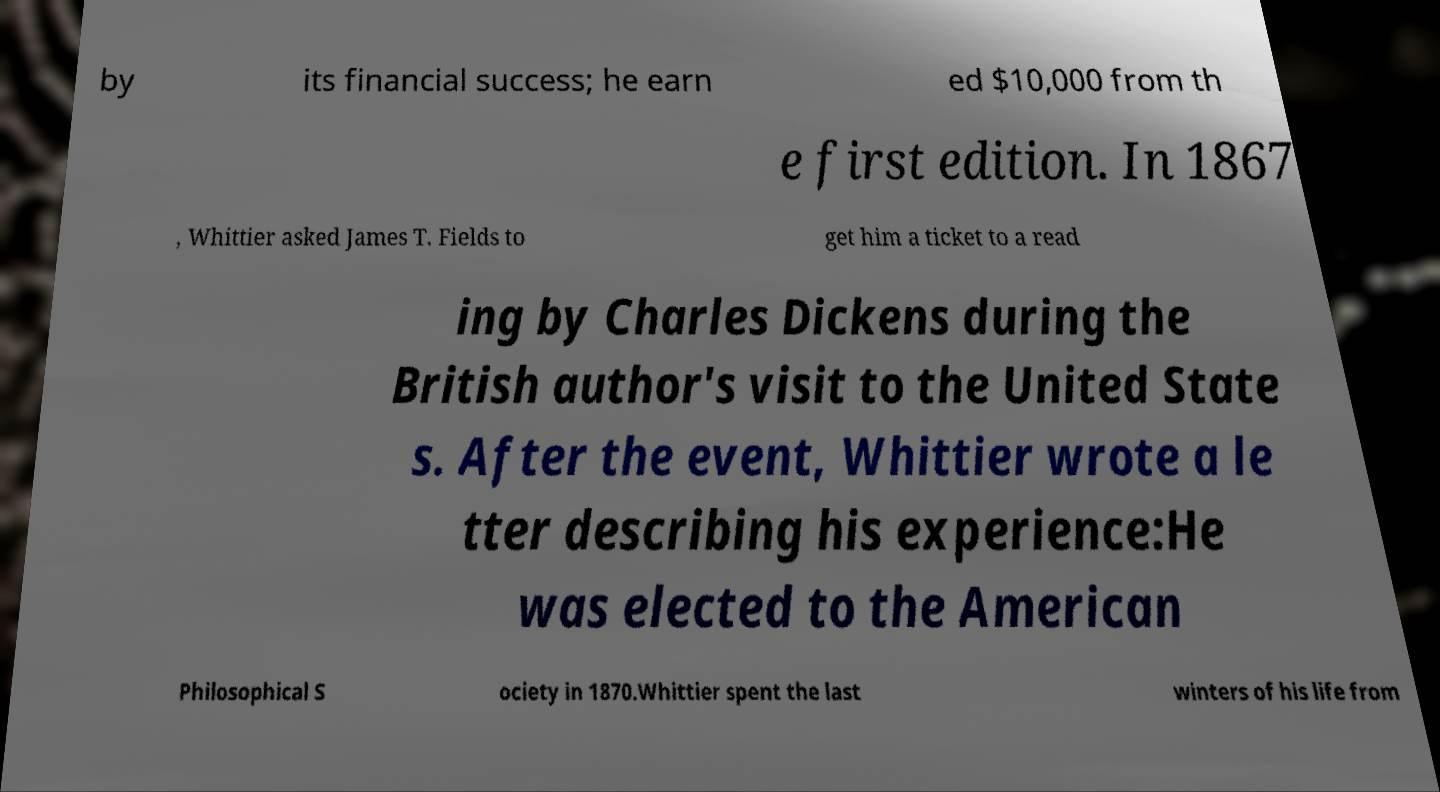For documentation purposes, I need the text within this image transcribed. Could you provide that? by its financial success; he earn ed $10,000 from th e first edition. In 1867 , Whittier asked James T. Fields to get him a ticket to a read ing by Charles Dickens during the British author's visit to the United State s. After the event, Whittier wrote a le tter describing his experience:He was elected to the American Philosophical S ociety in 1870.Whittier spent the last winters of his life from 